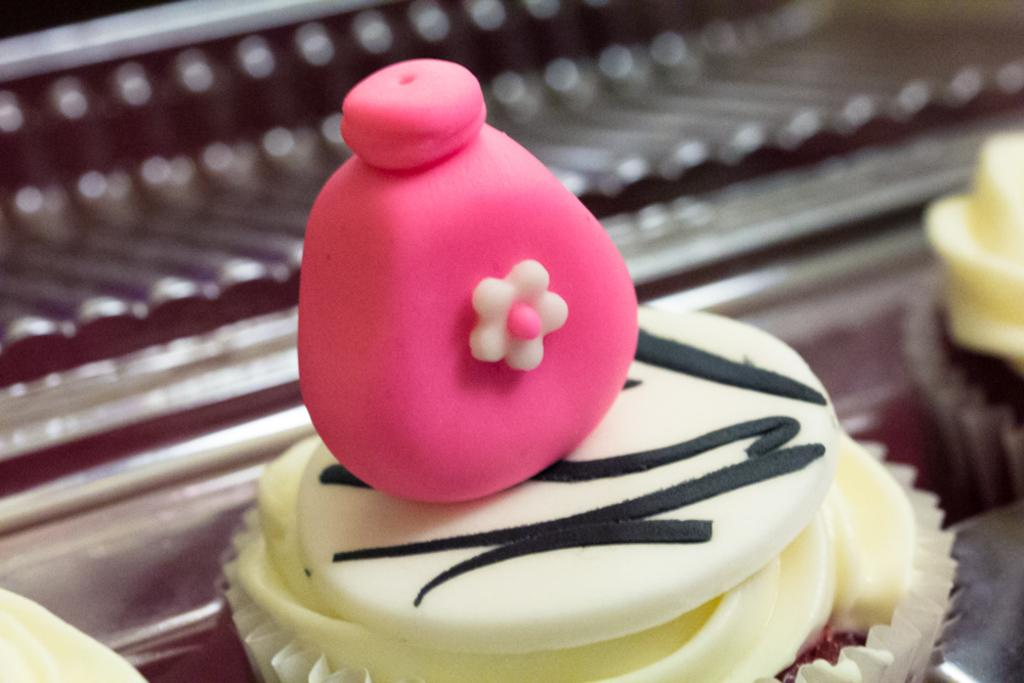What is the main subject of the image? There is a cupcake in the center of the image. How does the cupcake show affection to the person next to it in the image? The cupcake does not show affection or engage in any actions in the image, as it is an inanimate object. 